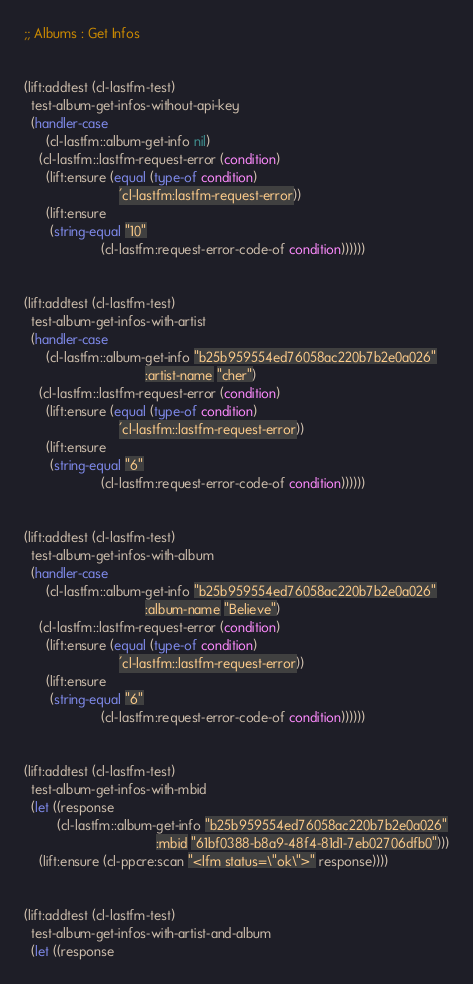<code> <loc_0><loc_0><loc_500><loc_500><_Lisp_>


;; Albums : Get Infos


(lift:addtest (cl-lastfm-test)
  test-album-get-infos-without-api-key
  (handler-case 
      (cl-lastfm::album-get-info nil)
    (cl-lastfm::lastfm-request-error (condition)
      (lift:ensure (equal (type-of condition)
                          'cl-lastfm:lastfm-request-error))
      (lift:ensure
       (string-equal "10"
                     (cl-lastfm:request-error-code-of condition))))))


(lift:addtest (cl-lastfm-test)
  test-album-get-infos-with-artist
  (handler-case 
      (cl-lastfm::album-get-info "b25b959554ed76058ac220b7b2e0a026"
                                 :artist-name "cher")
    (cl-lastfm::lastfm-request-error (condition)
      (lift:ensure (equal (type-of condition)
                          'cl-lastfm::lastfm-request-error))
      (lift:ensure
       (string-equal "6"
                     (cl-lastfm:request-error-code-of condition))))))


(lift:addtest (cl-lastfm-test)
  test-album-get-infos-with-album
  (handler-case 
      (cl-lastfm::album-get-info "b25b959554ed76058ac220b7b2e0a026"
                                 :album-name "Believe")
    (cl-lastfm::lastfm-request-error (condition)
      (lift:ensure (equal (type-of condition)
                          'cl-lastfm::lastfm-request-error))
      (lift:ensure
       (string-equal "6"
                     (cl-lastfm:request-error-code-of condition))))))


(lift:addtest (cl-lastfm-test)
  test-album-get-infos-with-mbid
  (let ((response
         (cl-lastfm::album-get-info "b25b959554ed76058ac220b7b2e0a026"
                                    :mbid "61bf0388-b8a9-48f4-81d1-7eb02706dfb0")))
    (lift:ensure (cl-ppcre:scan "<lfm status=\"ok\">" response))))


(lift:addtest (cl-lastfm-test)
  test-album-get-infos-with-artist-and-album
  (let ((response</code> 